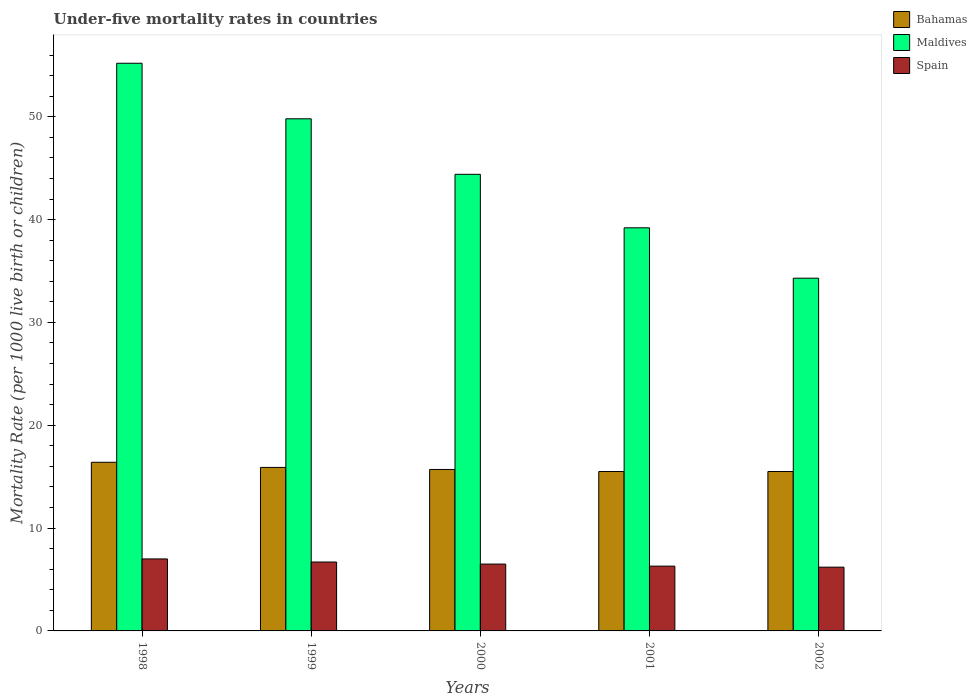Are the number of bars on each tick of the X-axis equal?
Provide a short and direct response. Yes. How many bars are there on the 4th tick from the left?
Your response must be concise. 3. In how many cases, is the number of bars for a given year not equal to the number of legend labels?
Offer a terse response. 0. What is the under-five mortality rate in Maldives in 1998?
Offer a terse response. 55.2. Across all years, what is the minimum under-five mortality rate in Spain?
Provide a succinct answer. 6.2. In which year was the under-five mortality rate in Bahamas maximum?
Offer a terse response. 1998. What is the total under-five mortality rate in Spain in the graph?
Ensure brevity in your answer.  32.7. What is the difference between the under-five mortality rate in Bahamas in 2001 and that in 2002?
Make the answer very short. 0. What is the average under-five mortality rate in Spain per year?
Make the answer very short. 6.54. In the year 2000, what is the difference between the under-five mortality rate in Bahamas and under-five mortality rate in Maldives?
Make the answer very short. -28.7. What is the ratio of the under-five mortality rate in Maldives in 2000 to that in 2002?
Your response must be concise. 1.29. What is the difference between the highest and the second highest under-five mortality rate in Bahamas?
Your response must be concise. 0.5. What is the difference between the highest and the lowest under-five mortality rate in Bahamas?
Keep it short and to the point. 0.9. Is the sum of the under-five mortality rate in Bahamas in 1998 and 2001 greater than the maximum under-five mortality rate in Spain across all years?
Ensure brevity in your answer.  Yes. What does the 3rd bar from the left in 1999 represents?
Provide a short and direct response. Spain. What does the 2nd bar from the right in 1999 represents?
Ensure brevity in your answer.  Maldives. Is it the case that in every year, the sum of the under-five mortality rate in Spain and under-five mortality rate in Maldives is greater than the under-five mortality rate in Bahamas?
Keep it short and to the point. Yes. Are all the bars in the graph horizontal?
Ensure brevity in your answer.  No. What is the difference between two consecutive major ticks on the Y-axis?
Provide a succinct answer. 10. What is the title of the graph?
Ensure brevity in your answer.  Under-five mortality rates in countries. What is the label or title of the Y-axis?
Provide a short and direct response. Mortality Rate (per 1000 live birth or children). What is the Mortality Rate (per 1000 live birth or children) of Bahamas in 1998?
Your response must be concise. 16.4. What is the Mortality Rate (per 1000 live birth or children) in Maldives in 1998?
Your answer should be compact. 55.2. What is the Mortality Rate (per 1000 live birth or children) in Spain in 1998?
Your answer should be very brief. 7. What is the Mortality Rate (per 1000 live birth or children) in Bahamas in 1999?
Your answer should be very brief. 15.9. What is the Mortality Rate (per 1000 live birth or children) of Maldives in 1999?
Your answer should be compact. 49.8. What is the Mortality Rate (per 1000 live birth or children) of Spain in 1999?
Your answer should be very brief. 6.7. What is the Mortality Rate (per 1000 live birth or children) of Maldives in 2000?
Keep it short and to the point. 44.4. What is the Mortality Rate (per 1000 live birth or children) in Spain in 2000?
Your answer should be compact. 6.5. What is the Mortality Rate (per 1000 live birth or children) in Maldives in 2001?
Your answer should be very brief. 39.2. What is the Mortality Rate (per 1000 live birth or children) in Spain in 2001?
Ensure brevity in your answer.  6.3. What is the Mortality Rate (per 1000 live birth or children) of Bahamas in 2002?
Your response must be concise. 15.5. What is the Mortality Rate (per 1000 live birth or children) of Maldives in 2002?
Make the answer very short. 34.3. What is the Mortality Rate (per 1000 live birth or children) in Spain in 2002?
Make the answer very short. 6.2. Across all years, what is the maximum Mortality Rate (per 1000 live birth or children) in Bahamas?
Your answer should be compact. 16.4. Across all years, what is the maximum Mortality Rate (per 1000 live birth or children) in Maldives?
Provide a succinct answer. 55.2. Across all years, what is the minimum Mortality Rate (per 1000 live birth or children) of Maldives?
Make the answer very short. 34.3. What is the total Mortality Rate (per 1000 live birth or children) in Bahamas in the graph?
Your answer should be very brief. 79. What is the total Mortality Rate (per 1000 live birth or children) in Maldives in the graph?
Give a very brief answer. 222.9. What is the total Mortality Rate (per 1000 live birth or children) of Spain in the graph?
Provide a short and direct response. 32.7. What is the difference between the Mortality Rate (per 1000 live birth or children) of Spain in 1998 and that in 2001?
Provide a succinct answer. 0.7. What is the difference between the Mortality Rate (per 1000 live birth or children) of Maldives in 1998 and that in 2002?
Your answer should be very brief. 20.9. What is the difference between the Mortality Rate (per 1000 live birth or children) of Spain in 1998 and that in 2002?
Ensure brevity in your answer.  0.8. What is the difference between the Mortality Rate (per 1000 live birth or children) in Bahamas in 1999 and that in 2000?
Your response must be concise. 0.2. What is the difference between the Mortality Rate (per 1000 live birth or children) of Maldives in 1999 and that in 2000?
Your answer should be very brief. 5.4. What is the difference between the Mortality Rate (per 1000 live birth or children) in Bahamas in 1999 and that in 2001?
Your answer should be compact. 0.4. What is the difference between the Mortality Rate (per 1000 live birth or children) in Spain in 1999 and that in 2001?
Provide a short and direct response. 0.4. What is the difference between the Mortality Rate (per 1000 live birth or children) of Bahamas in 1999 and that in 2002?
Provide a short and direct response. 0.4. What is the difference between the Mortality Rate (per 1000 live birth or children) in Maldives in 1999 and that in 2002?
Your answer should be very brief. 15.5. What is the difference between the Mortality Rate (per 1000 live birth or children) in Spain in 1999 and that in 2002?
Offer a terse response. 0.5. What is the difference between the Mortality Rate (per 1000 live birth or children) of Spain in 2000 and that in 2001?
Ensure brevity in your answer.  0.2. What is the difference between the Mortality Rate (per 1000 live birth or children) in Bahamas in 2000 and that in 2002?
Offer a terse response. 0.2. What is the difference between the Mortality Rate (per 1000 live birth or children) in Maldives in 2000 and that in 2002?
Your answer should be compact. 10.1. What is the difference between the Mortality Rate (per 1000 live birth or children) in Spain in 2000 and that in 2002?
Offer a terse response. 0.3. What is the difference between the Mortality Rate (per 1000 live birth or children) of Maldives in 2001 and that in 2002?
Offer a very short reply. 4.9. What is the difference between the Mortality Rate (per 1000 live birth or children) of Spain in 2001 and that in 2002?
Give a very brief answer. 0.1. What is the difference between the Mortality Rate (per 1000 live birth or children) in Bahamas in 1998 and the Mortality Rate (per 1000 live birth or children) in Maldives in 1999?
Your answer should be compact. -33.4. What is the difference between the Mortality Rate (per 1000 live birth or children) of Bahamas in 1998 and the Mortality Rate (per 1000 live birth or children) of Spain in 1999?
Keep it short and to the point. 9.7. What is the difference between the Mortality Rate (per 1000 live birth or children) in Maldives in 1998 and the Mortality Rate (per 1000 live birth or children) in Spain in 1999?
Offer a very short reply. 48.5. What is the difference between the Mortality Rate (per 1000 live birth or children) of Maldives in 1998 and the Mortality Rate (per 1000 live birth or children) of Spain in 2000?
Give a very brief answer. 48.7. What is the difference between the Mortality Rate (per 1000 live birth or children) in Bahamas in 1998 and the Mortality Rate (per 1000 live birth or children) in Maldives in 2001?
Provide a succinct answer. -22.8. What is the difference between the Mortality Rate (per 1000 live birth or children) in Maldives in 1998 and the Mortality Rate (per 1000 live birth or children) in Spain in 2001?
Your answer should be very brief. 48.9. What is the difference between the Mortality Rate (per 1000 live birth or children) of Bahamas in 1998 and the Mortality Rate (per 1000 live birth or children) of Maldives in 2002?
Keep it short and to the point. -17.9. What is the difference between the Mortality Rate (per 1000 live birth or children) of Maldives in 1998 and the Mortality Rate (per 1000 live birth or children) of Spain in 2002?
Make the answer very short. 49. What is the difference between the Mortality Rate (per 1000 live birth or children) of Bahamas in 1999 and the Mortality Rate (per 1000 live birth or children) of Maldives in 2000?
Offer a terse response. -28.5. What is the difference between the Mortality Rate (per 1000 live birth or children) of Bahamas in 1999 and the Mortality Rate (per 1000 live birth or children) of Spain in 2000?
Provide a succinct answer. 9.4. What is the difference between the Mortality Rate (per 1000 live birth or children) of Maldives in 1999 and the Mortality Rate (per 1000 live birth or children) of Spain in 2000?
Offer a terse response. 43.3. What is the difference between the Mortality Rate (per 1000 live birth or children) in Bahamas in 1999 and the Mortality Rate (per 1000 live birth or children) in Maldives in 2001?
Your answer should be very brief. -23.3. What is the difference between the Mortality Rate (per 1000 live birth or children) in Maldives in 1999 and the Mortality Rate (per 1000 live birth or children) in Spain in 2001?
Provide a succinct answer. 43.5. What is the difference between the Mortality Rate (per 1000 live birth or children) of Bahamas in 1999 and the Mortality Rate (per 1000 live birth or children) of Maldives in 2002?
Keep it short and to the point. -18.4. What is the difference between the Mortality Rate (per 1000 live birth or children) of Maldives in 1999 and the Mortality Rate (per 1000 live birth or children) of Spain in 2002?
Your answer should be compact. 43.6. What is the difference between the Mortality Rate (per 1000 live birth or children) in Bahamas in 2000 and the Mortality Rate (per 1000 live birth or children) in Maldives in 2001?
Give a very brief answer. -23.5. What is the difference between the Mortality Rate (per 1000 live birth or children) of Bahamas in 2000 and the Mortality Rate (per 1000 live birth or children) of Spain in 2001?
Ensure brevity in your answer.  9.4. What is the difference between the Mortality Rate (per 1000 live birth or children) in Maldives in 2000 and the Mortality Rate (per 1000 live birth or children) in Spain in 2001?
Your answer should be very brief. 38.1. What is the difference between the Mortality Rate (per 1000 live birth or children) of Bahamas in 2000 and the Mortality Rate (per 1000 live birth or children) of Maldives in 2002?
Offer a very short reply. -18.6. What is the difference between the Mortality Rate (per 1000 live birth or children) of Bahamas in 2000 and the Mortality Rate (per 1000 live birth or children) of Spain in 2002?
Your response must be concise. 9.5. What is the difference between the Mortality Rate (per 1000 live birth or children) of Maldives in 2000 and the Mortality Rate (per 1000 live birth or children) of Spain in 2002?
Give a very brief answer. 38.2. What is the difference between the Mortality Rate (per 1000 live birth or children) in Bahamas in 2001 and the Mortality Rate (per 1000 live birth or children) in Maldives in 2002?
Provide a succinct answer. -18.8. What is the difference between the Mortality Rate (per 1000 live birth or children) of Bahamas in 2001 and the Mortality Rate (per 1000 live birth or children) of Spain in 2002?
Ensure brevity in your answer.  9.3. What is the difference between the Mortality Rate (per 1000 live birth or children) in Maldives in 2001 and the Mortality Rate (per 1000 live birth or children) in Spain in 2002?
Offer a very short reply. 33. What is the average Mortality Rate (per 1000 live birth or children) of Maldives per year?
Give a very brief answer. 44.58. What is the average Mortality Rate (per 1000 live birth or children) of Spain per year?
Offer a terse response. 6.54. In the year 1998, what is the difference between the Mortality Rate (per 1000 live birth or children) in Bahamas and Mortality Rate (per 1000 live birth or children) in Maldives?
Offer a very short reply. -38.8. In the year 1998, what is the difference between the Mortality Rate (per 1000 live birth or children) of Bahamas and Mortality Rate (per 1000 live birth or children) of Spain?
Provide a succinct answer. 9.4. In the year 1998, what is the difference between the Mortality Rate (per 1000 live birth or children) in Maldives and Mortality Rate (per 1000 live birth or children) in Spain?
Provide a succinct answer. 48.2. In the year 1999, what is the difference between the Mortality Rate (per 1000 live birth or children) of Bahamas and Mortality Rate (per 1000 live birth or children) of Maldives?
Keep it short and to the point. -33.9. In the year 1999, what is the difference between the Mortality Rate (per 1000 live birth or children) of Bahamas and Mortality Rate (per 1000 live birth or children) of Spain?
Provide a succinct answer. 9.2. In the year 1999, what is the difference between the Mortality Rate (per 1000 live birth or children) of Maldives and Mortality Rate (per 1000 live birth or children) of Spain?
Provide a short and direct response. 43.1. In the year 2000, what is the difference between the Mortality Rate (per 1000 live birth or children) of Bahamas and Mortality Rate (per 1000 live birth or children) of Maldives?
Give a very brief answer. -28.7. In the year 2000, what is the difference between the Mortality Rate (per 1000 live birth or children) in Maldives and Mortality Rate (per 1000 live birth or children) in Spain?
Offer a very short reply. 37.9. In the year 2001, what is the difference between the Mortality Rate (per 1000 live birth or children) in Bahamas and Mortality Rate (per 1000 live birth or children) in Maldives?
Provide a short and direct response. -23.7. In the year 2001, what is the difference between the Mortality Rate (per 1000 live birth or children) in Maldives and Mortality Rate (per 1000 live birth or children) in Spain?
Provide a short and direct response. 32.9. In the year 2002, what is the difference between the Mortality Rate (per 1000 live birth or children) of Bahamas and Mortality Rate (per 1000 live birth or children) of Maldives?
Keep it short and to the point. -18.8. In the year 2002, what is the difference between the Mortality Rate (per 1000 live birth or children) in Bahamas and Mortality Rate (per 1000 live birth or children) in Spain?
Your response must be concise. 9.3. In the year 2002, what is the difference between the Mortality Rate (per 1000 live birth or children) in Maldives and Mortality Rate (per 1000 live birth or children) in Spain?
Your answer should be compact. 28.1. What is the ratio of the Mortality Rate (per 1000 live birth or children) of Bahamas in 1998 to that in 1999?
Your answer should be compact. 1.03. What is the ratio of the Mortality Rate (per 1000 live birth or children) in Maldives in 1998 to that in 1999?
Provide a succinct answer. 1.11. What is the ratio of the Mortality Rate (per 1000 live birth or children) in Spain in 1998 to that in 1999?
Give a very brief answer. 1.04. What is the ratio of the Mortality Rate (per 1000 live birth or children) of Bahamas in 1998 to that in 2000?
Your answer should be compact. 1.04. What is the ratio of the Mortality Rate (per 1000 live birth or children) of Maldives in 1998 to that in 2000?
Make the answer very short. 1.24. What is the ratio of the Mortality Rate (per 1000 live birth or children) in Spain in 1998 to that in 2000?
Your response must be concise. 1.08. What is the ratio of the Mortality Rate (per 1000 live birth or children) of Bahamas in 1998 to that in 2001?
Offer a very short reply. 1.06. What is the ratio of the Mortality Rate (per 1000 live birth or children) in Maldives in 1998 to that in 2001?
Ensure brevity in your answer.  1.41. What is the ratio of the Mortality Rate (per 1000 live birth or children) in Spain in 1998 to that in 2001?
Your response must be concise. 1.11. What is the ratio of the Mortality Rate (per 1000 live birth or children) of Bahamas in 1998 to that in 2002?
Keep it short and to the point. 1.06. What is the ratio of the Mortality Rate (per 1000 live birth or children) in Maldives in 1998 to that in 2002?
Your answer should be compact. 1.61. What is the ratio of the Mortality Rate (per 1000 live birth or children) of Spain in 1998 to that in 2002?
Keep it short and to the point. 1.13. What is the ratio of the Mortality Rate (per 1000 live birth or children) of Bahamas in 1999 to that in 2000?
Provide a succinct answer. 1.01. What is the ratio of the Mortality Rate (per 1000 live birth or children) in Maldives in 1999 to that in 2000?
Give a very brief answer. 1.12. What is the ratio of the Mortality Rate (per 1000 live birth or children) in Spain in 1999 to that in 2000?
Provide a short and direct response. 1.03. What is the ratio of the Mortality Rate (per 1000 live birth or children) in Bahamas in 1999 to that in 2001?
Offer a terse response. 1.03. What is the ratio of the Mortality Rate (per 1000 live birth or children) in Maldives in 1999 to that in 2001?
Ensure brevity in your answer.  1.27. What is the ratio of the Mortality Rate (per 1000 live birth or children) of Spain in 1999 to that in 2001?
Your answer should be very brief. 1.06. What is the ratio of the Mortality Rate (per 1000 live birth or children) of Bahamas in 1999 to that in 2002?
Make the answer very short. 1.03. What is the ratio of the Mortality Rate (per 1000 live birth or children) in Maldives in 1999 to that in 2002?
Ensure brevity in your answer.  1.45. What is the ratio of the Mortality Rate (per 1000 live birth or children) in Spain in 1999 to that in 2002?
Provide a succinct answer. 1.08. What is the ratio of the Mortality Rate (per 1000 live birth or children) of Bahamas in 2000 to that in 2001?
Provide a succinct answer. 1.01. What is the ratio of the Mortality Rate (per 1000 live birth or children) of Maldives in 2000 to that in 2001?
Your answer should be compact. 1.13. What is the ratio of the Mortality Rate (per 1000 live birth or children) of Spain in 2000 to that in 2001?
Keep it short and to the point. 1.03. What is the ratio of the Mortality Rate (per 1000 live birth or children) of Bahamas in 2000 to that in 2002?
Offer a very short reply. 1.01. What is the ratio of the Mortality Rate (per 1000 live birth or children) in Maldives in 2000 to that in 2002?
Give a very brief answer. 1.29. What is the ratio of the Mortality Rate (per 1000 live birth or children) in Spain in 2000 to that in 2002?
Ensure brevity in your answer.  1.05. What is the ratio of the Mortality Rate (per 1000 live birth or children) of Bahamas in 2001 to that in 2002?
Offer a very short reply. 1. What is the ratio of the Mortality Rate (per 1000 live birth or children) in Maldives in 2001 to that in 2002?
Provide a succinct answer. 1.14. What is the ratio of the Mortality Rate (per 1000 live birth or children) in Spain in 2001 to that in 2002?
Offer a very short reply. 1.02. What is the difference between the highest and the second highest Mortality Rate (per 1000 live birth or children) of Maldives?
Your response must be concise. 5.4. What is the difference between the highest and the lowest Mortality Rate (per 1000 live birth or children) of Maldives?
Offer a terse response. 20.9. What is the difference between the highest and the lowest Mortality Rate (per 1000 live birth or children) of Spain?
Give a very brief answer. 0.8. 